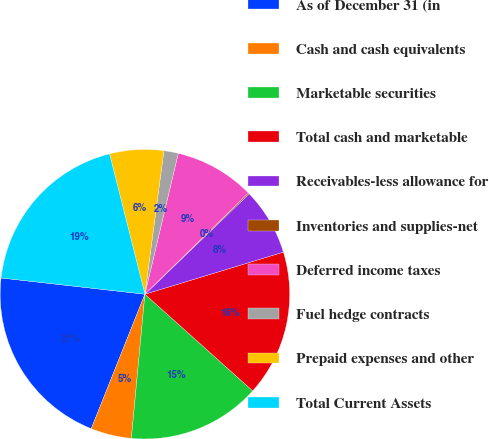<chart> <loc_0><loc_0><loc_500><loc_500><pie_chart><fcel>As of December 31 (in<fcel>Cash and cash equivalents<fcel>Marketable securities<fcel>Total cash and marketable<fcel>Receivables-less allowance for<fcel>Inventories and supplies-net<fcel>Deferred income taxes<fcel>Fuel hedge contracts<fcel>Prepaid expenses and other<fcel>Total Current Assets<nl><fcel>20.75%<fcel>4.55%<fcel>14.86%<fcel>16.33%<fcel>7.5%<fcel>0.13%<fcel>8.97%<fcel>1.61%<fcel>6.02%<fcel>19.28%<nl></chart> 